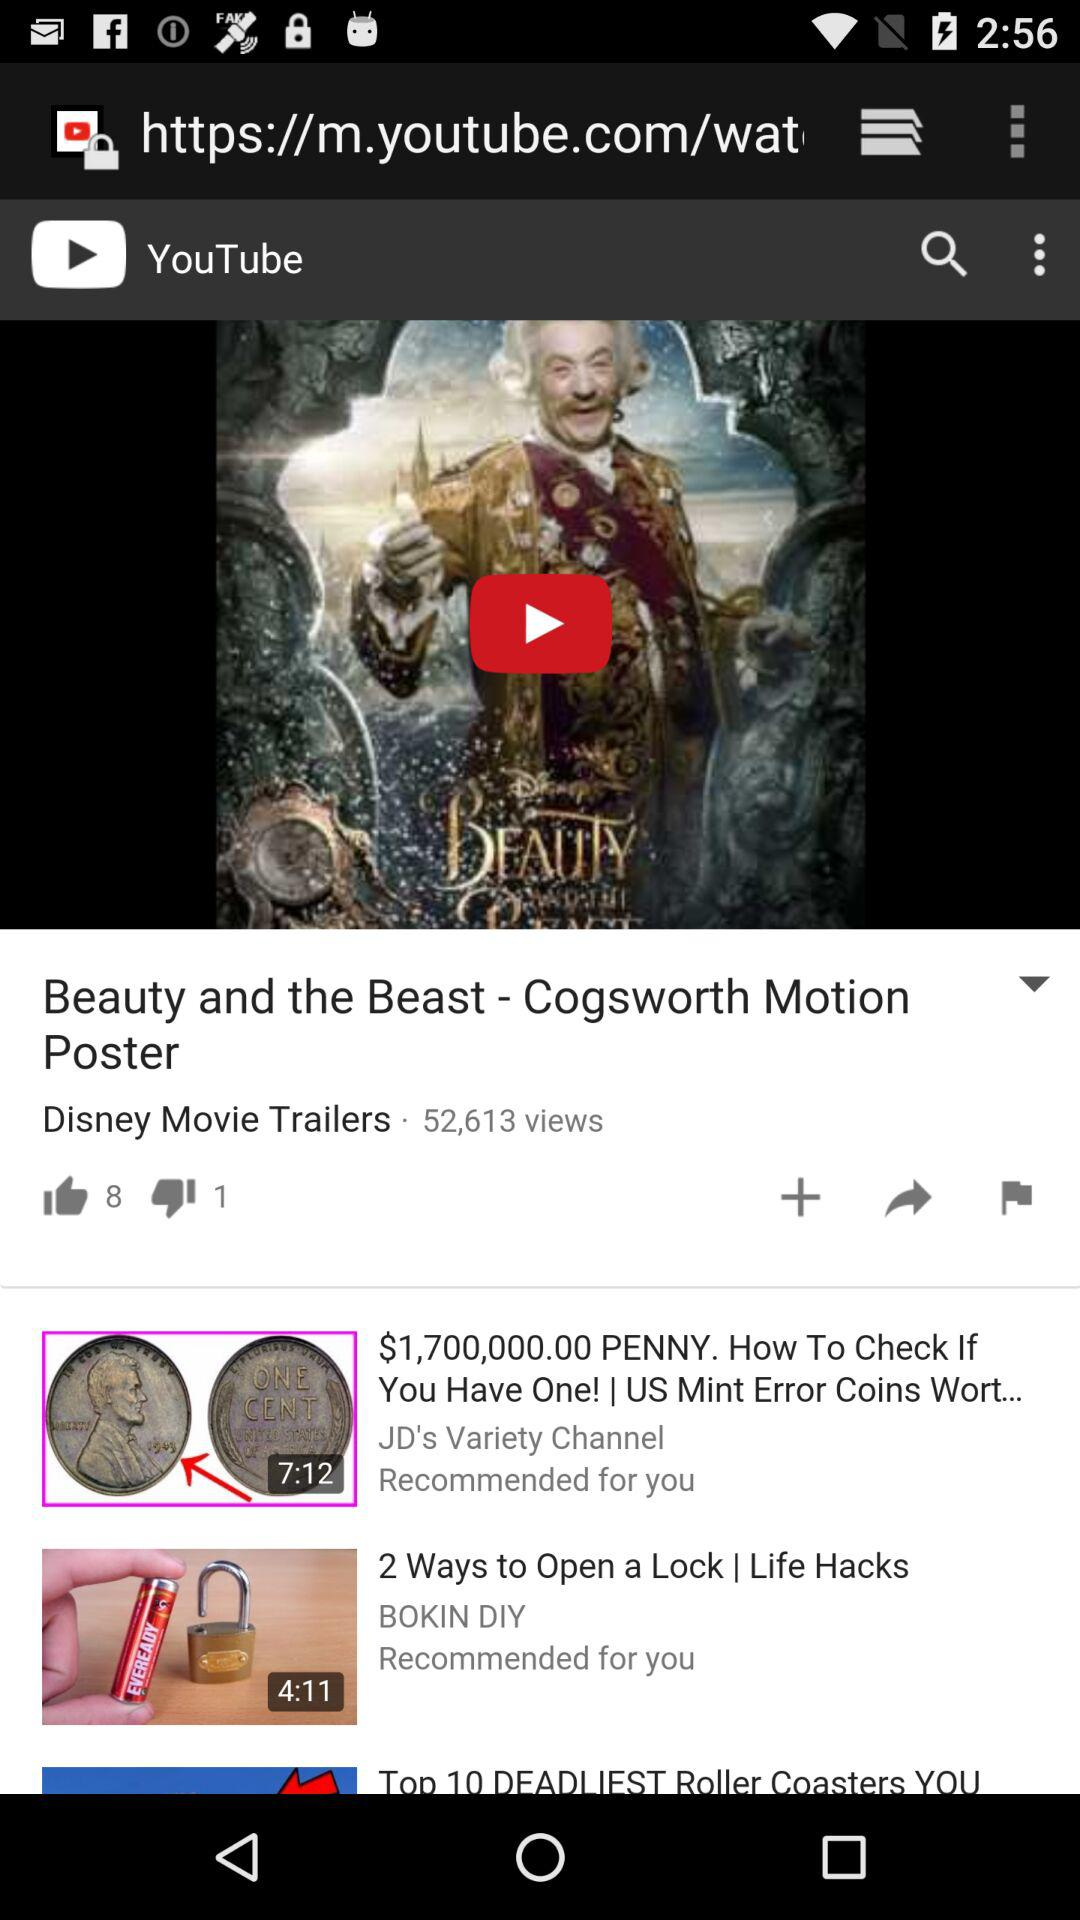How many thumbs up does the video have?
Answer the question using a single word or phrase. 8 